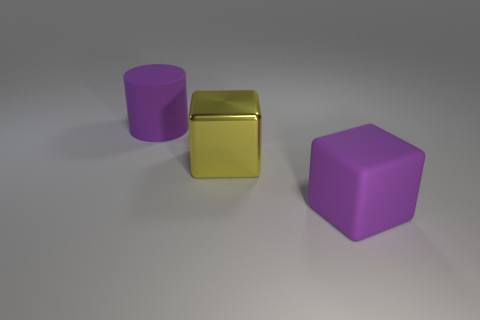There is a big purple thing that is behind the yellow thing; is it the same shape as the big shiny thing?
Make the answer very short. No. What number of other big yellow shiny objects are the same shape as the big yellow object?
Your response must be concise. 0. Is there a purple cube made of the same material as the yellow object?
Your response must be concise. No. There is a large purple thing that is left of the purple matte object that is in front of the rubber cylinder; what is its material?
Ensure brevity in your answer.  Rubber. How big is the purple rubber object that is to the right of the yellow thing?
Keep it short and to the point. Large. Do the rubber block and the rubber cylinder that is left of the purple rubber cube have the same color?
Provide a succinct answer. Yes. Is there another matte cylinder that has the same color as the cylinder?
Provide a succinct answer. No. Is the large yellow object made of the same material as the purple object on the right side of the large matte cylinder?
Offer a very short reply. No. What number of small objects are either yellow shiny things or purple cylinders?
Offer a very short reply. 0. What material is the big thing that is the same color as the big cylinder?
Offer a very short reply. Rubber. 